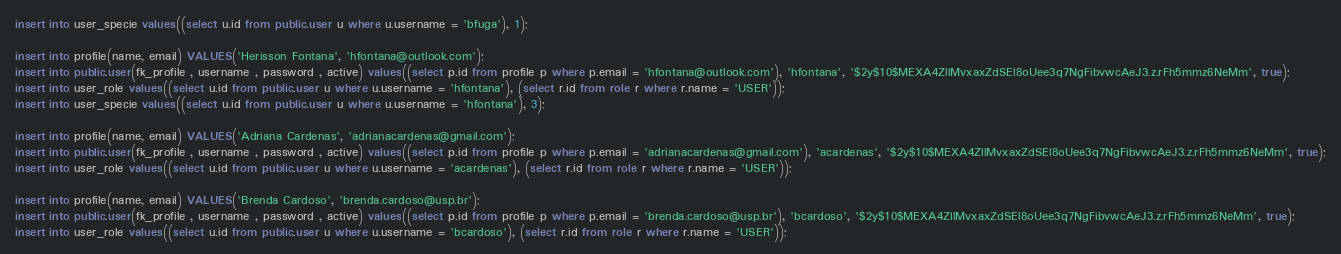Convert code to text. <code><loc_0><loc_0><loc_500><loc_500><_SQL_>insert into user_specie values((select u.id from public.user u where u.username = 'bfuga'), 1);

insert into profile(name, email) VALUES('Herisson Fontana', 'hfontana@outlook.com');
insert into public.user(fk_profile , username , password , active) values((select p.id from profile p where p.email = 'hfontana@outlook.com'), 'hfontana', '$2y$10$MEXA4ZllMvxaxZdSEl8oUee3q7NgFibvwcAeJ3.z.rFh5mmz6NeMm', true);
insert into user_role values((select u.id from public.user u where u.username = 'hfontana'), (select r.id from role r where r.name = 'USER'));
insert into user_specie values((select u.id from public.user u where u.username = 'hfontana'), 3);

insert into profile(name, email) VALUES('Adriana Cardenas', 'adrianacardenas@gmail.com');
insert into public.user(fk_profile , username , password , active) values((select p.id from profile p where p.email = 'adrianacardenas@gmail.com'), 'acardenas', '$2y$10$MEXA4ZllMvxaxZdSEl8oUee3q7NgFibvwcAeJ3.z.rFh5mmz6NeMm', true);
insert into user_role values((select u.id from public.user u where u.username = 'acardenas'), (select r.id from role r where r.name = 'USER'));

insert into profile(name, email) VALUES('Brenda Cardoso', 'brenda.cardoso@usp.br');
insert into public.user(fk_profile , username , password , active) values((select p.id from profile p where p.email = 'brenda.cardoso@usp.br'), 'bcardoso', '$2y$10$MEXA4ZllMvxaxZdSEl8oUee3q7NgFibvwcAeJ3.z.rFh5mmz6NeMm', true);
insert into user_role values((select u.id from public.user u where u.username = 'bcardoso'), (select r.id from role r where r.name = 'USER'));</code> 